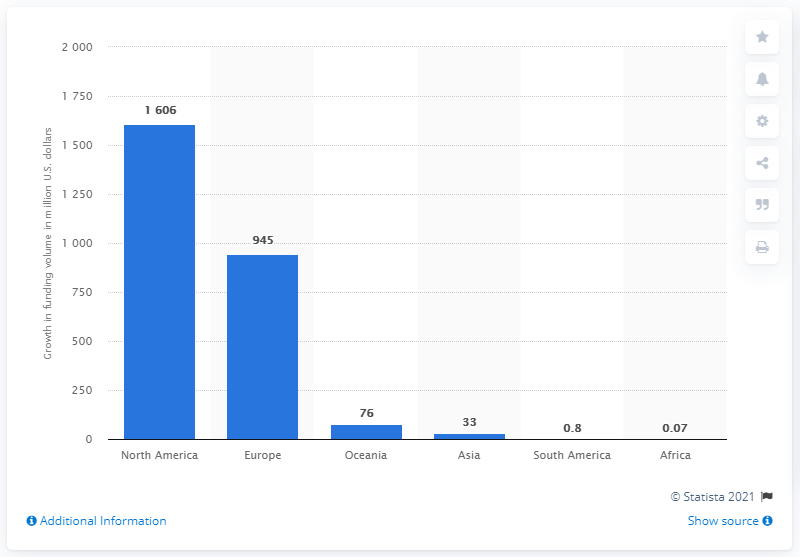Draw attention to some important aspects in this diagram. In 2012, North America region topped the list in terms of total funds raised. The total amount of funds raised in South America in 2012 was 0.8 billion dollars. 